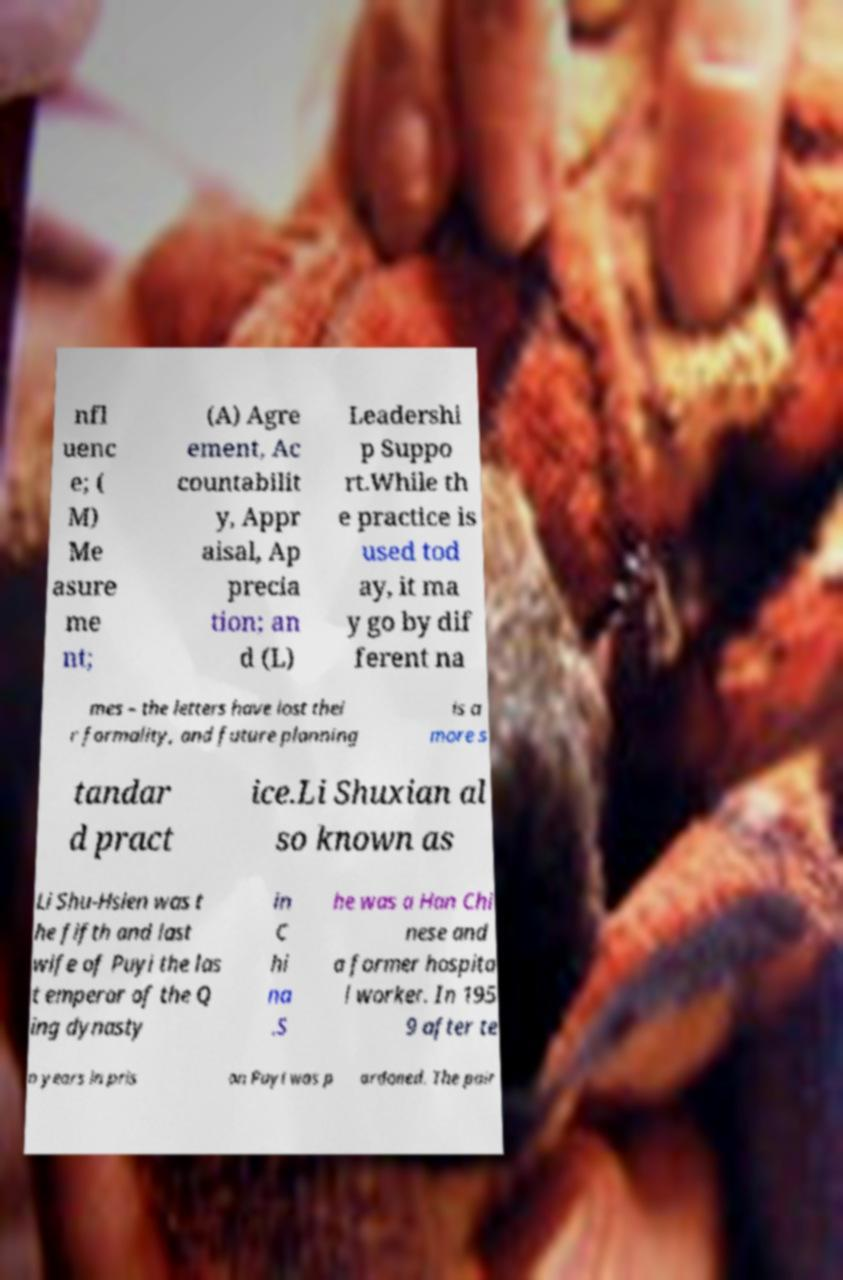Please read and relay the text visible in this image. What does it say? nfl uenc e; ( M) Me asure me nt; (A) Agre ement, Ac countabilit y, Appr aisal, Ap precia tion; an d (L) Leadershi p Suppo rt.While th e practice is used tod ay, it ma y go by dif ferent na mes – the letters have lost thei r formality, and future planning is a more s tandar d pract ice.Li Shuxian al so known as Li Shu-Hsien was t he fifth and last wife of Puyi the las t emperor of the Q ing dynasty in C hi na .S he was a Han Chi nese and a former hospita l worker. In 195 9 after te n years in pris on Puyi was p ardoned. The pair 